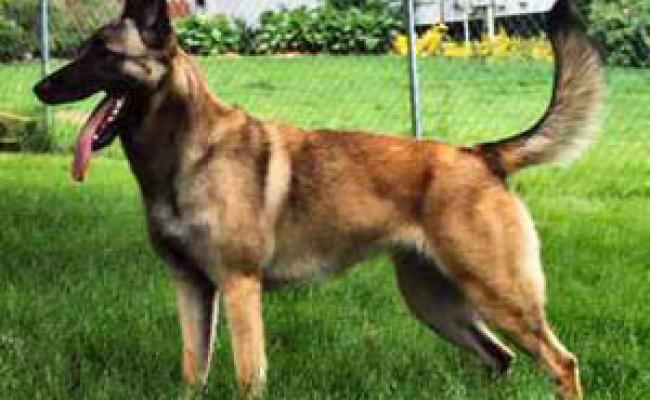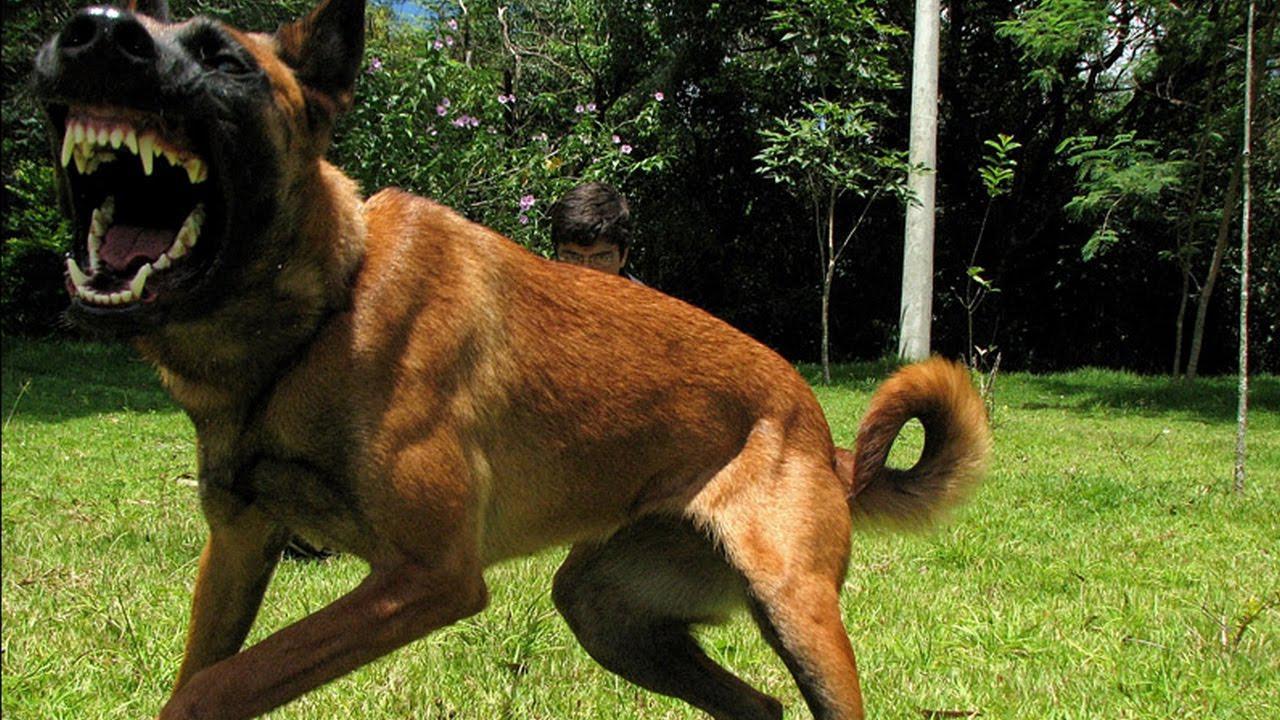The first image is the image on the left, the second image is the image on the right. For the images displayed, is the sentence "At least one dog is biting someone." factually correct? Answer yes or no. No. 